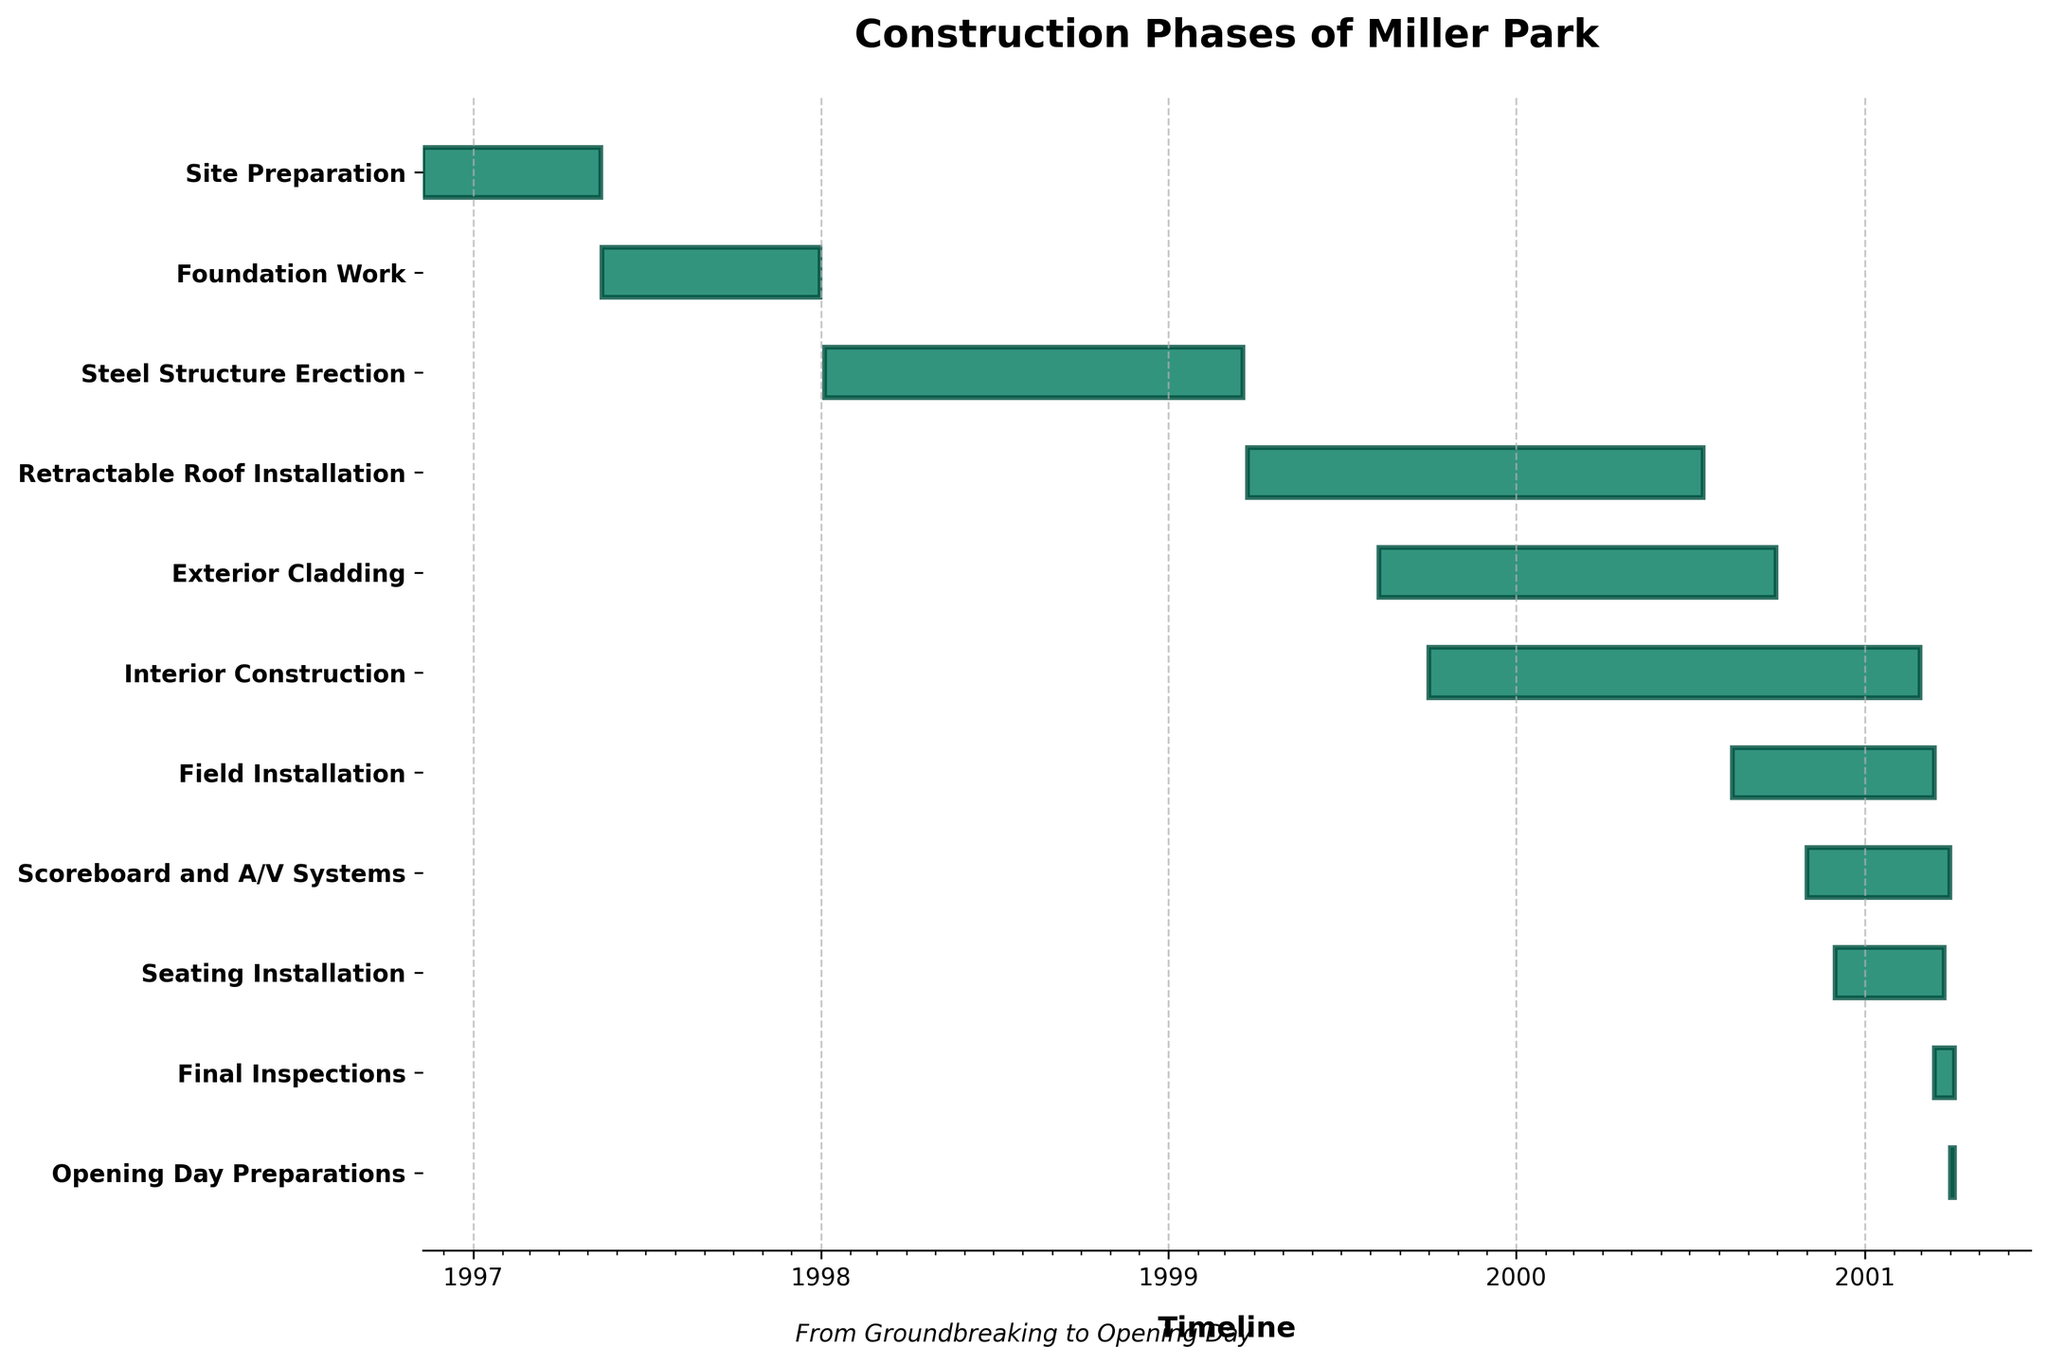When did the Site Preparation phase start and end? The Site Preparation phase's "Start Date" is given as 1996-11-09, and the "End Date" is 1997-05-15, based on the bars in the Gantt chart.
Answer: 1996-11-09 to 1997-05-15 Which construction phase took the longest time? By comparing the lengths of the horizontal bars for each phase, the Interior Construction phase, from 1999-10-01 to 2001-02-28, exceeds the others in duration.
Answer: Interior Construction How many phases overlapped with the Exterior Cladding phase? The Exterior Cladding phase ran from 1999-08-10 to 2000-09-30. Checking each phase, the Retractable Roof Installation, Interior Construction, Field Installation, Scoreboard and A/V Systems, and Seating Installation overlapped with this phase.
Answer: 5 What phase was in progress at the start of 1999? Checking the Gantt chart for 1999-01-01, the Steel Structure Erection phase was ongoing at that time.
Answer: Steel Structure Erection When did the Final Inspections phase occur? The Final Inspections phase started on 2001-03-15 and ended on 2001-04-05, as indicated by the Gantt chart timeline.
Answer: 2001-03-15 to 2001-04-05 How many phases extended into the year 2001? The phases that extend into 2001, based on the chart, are Interior Construction, Field Installation, Scoreboard and A/V Systems, Seating Installation, Final Inspections, and Opening Day Preparations.
Answer: 6 Which phase had the shortest duration and what was its length? By comparing the bars, Opening Day Preparations, from 2001-04-01 to 2001-04-05, is the shortest with a 5-day duration.
Answer: Opening Day Preparations, 5 days When did the Field Installation phase overlap with the Seating Installation phase? The Field Installation phase (2000-08-15 to 2001-03-15) and Seating Installation (2000-12-01 to 2001-03-25) overlapped from 2000-12-01 to 2001-03-15.
Answer: 2000-12-01 to 2001-03-15 Which two phases were completed last before the Opening Day Preparations? The two phases that finished last before Opening Day Preparations, based on the figure, are Seating Installation (ends 2001-03-25) and Scoreboard and A/V Systems (ends 2001-03-31).
Answer: Seating Installation and Scoreboard and A/V Systems 